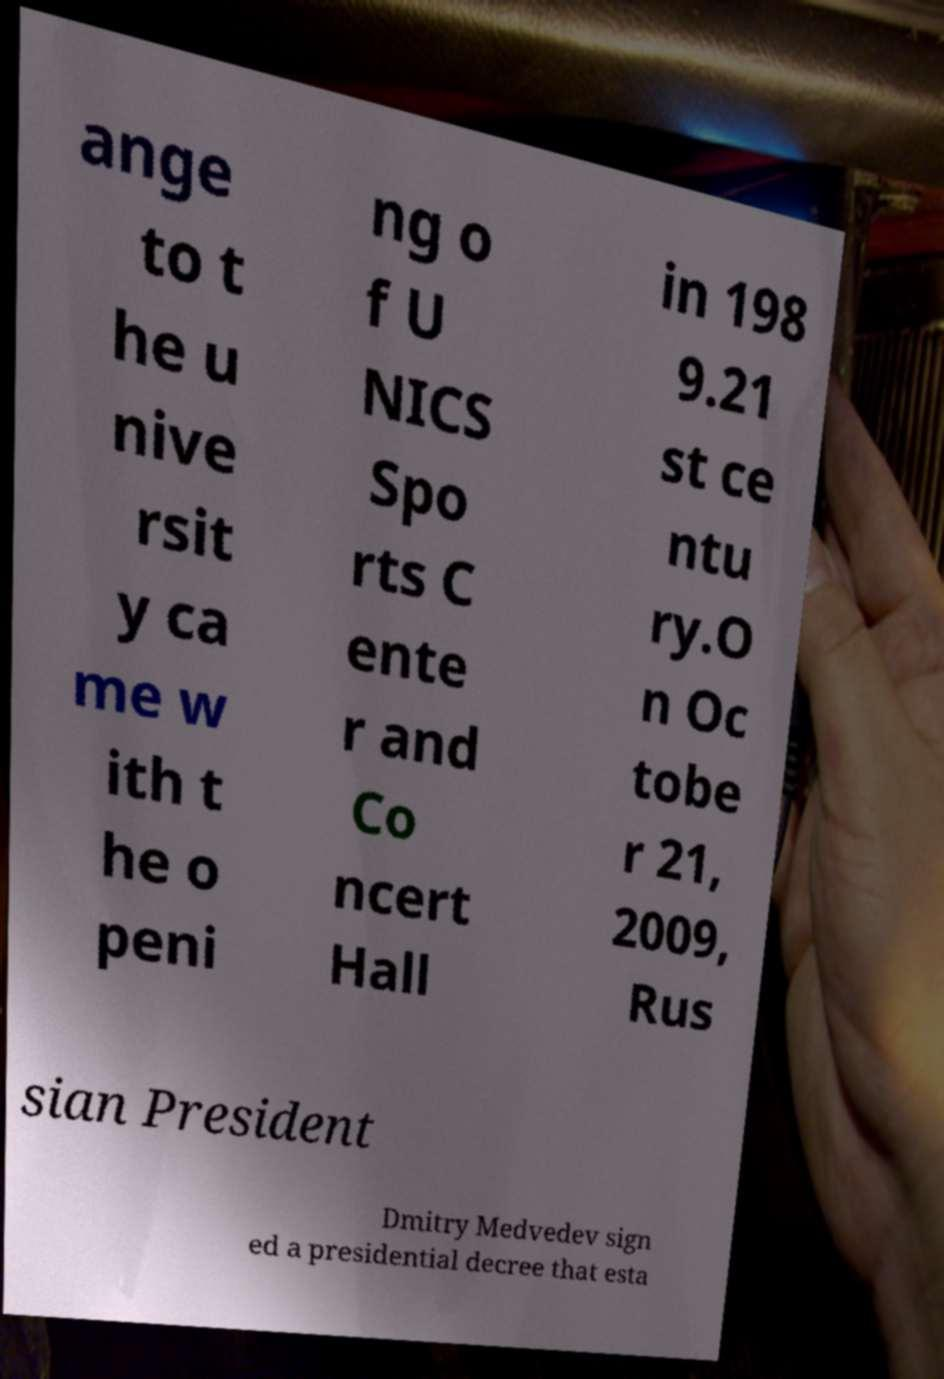I need the written content from this picture converted into text. Can you do that? ange to t he u nive rsit y ca me w ith t he o peni ng o f U NICS Spo rts C ente r and Co ncert Hall in 198 9.21 st ce ntu ry.O n Oc tobe r 21, 2009, Rus sian President Dmitry Medvedev sign ed a presidential decree that esta 